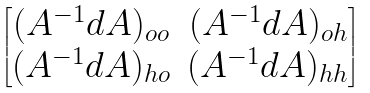<formula> <loc_0><loc_0><loc_500><loc_500>\begin{bmatrix} ( A ^ { - 1 } d A ) _ { o o } & ( A ^ { - 1 } d A ) _ { o h } \\ ( A ^ { - 1 } d A ) _ { h o } & ( A ^ { - 1 } d A ) _ { h h } \end{bmatrix}</formula> 